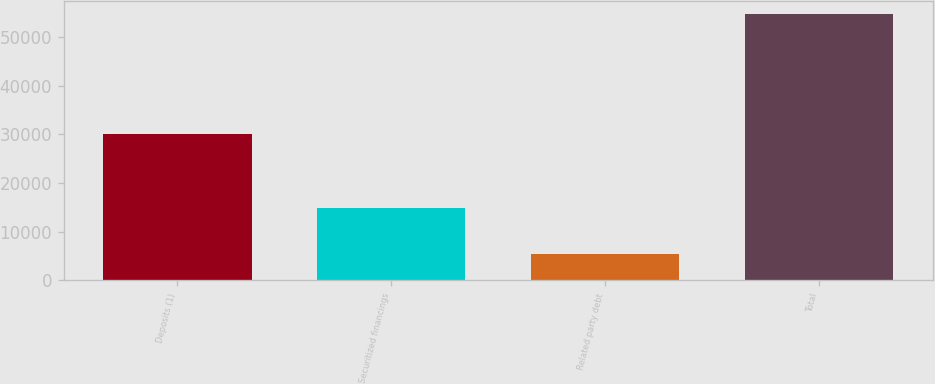Convert chart to OTSL. <chart><loc_0><loc_0><loc_500><loc_500><bar_chart><fcel>Deposits (1)<fcel>Securitized financings<fcel>Related party debt<fcel>Total<nl><fcel>30110<fcel>14835<fcel>5335<fcel>54718<nl></chart> 